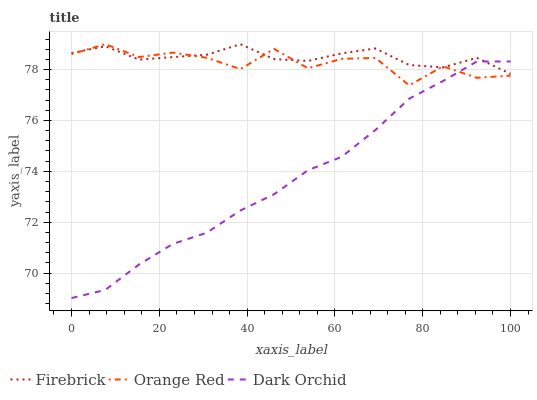Does Dark Orchid have the minimum area under the curve?
Answer yes or no. Yes. Does Firebrick have the maximum area under the curve?
Answer yes or no. Yes. Does Orange Red have the minimum area under the curve?
Answer yes or no. No. Does Orange Red have the maximum area under the curve?
Answer yes or no. No. Is Dark Orchid the smoothest?
Answer yes or no. Yes. Is Orange Red the roughest?
Answer yes or no. Yes. Is Orange Red the smoothest?
Answer yes or no. No. Is Dark Orchid the roughest?
Answer yes or no. No. Does Dark Orchid have the lowest value?
Answer yes or no. Yes. Does Orange Red have the lowest value?
Answer yes or no. No. Does Orange Red have the highest value?
Answer yes or no. Yes. Does Dark Orchid have the highest value?
Answer yes or no. No. Does Dark Orchid intersect Firebrick?
Answer yes or no. Yes. Is Dark Orchid less than Firebrick?
Answer yes or no. No. Is Dark Orchid greater than Firebrick?
Answer yes or no. No. 